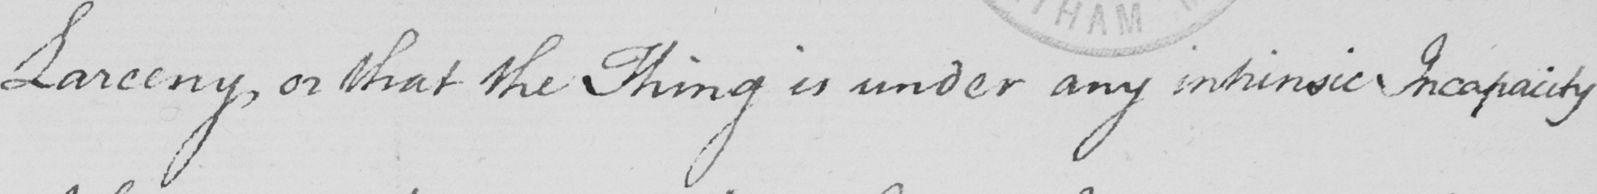Please provide the text content of this handwritten line. Larceny , or that the Thing is under any intrinsic Incapacity 